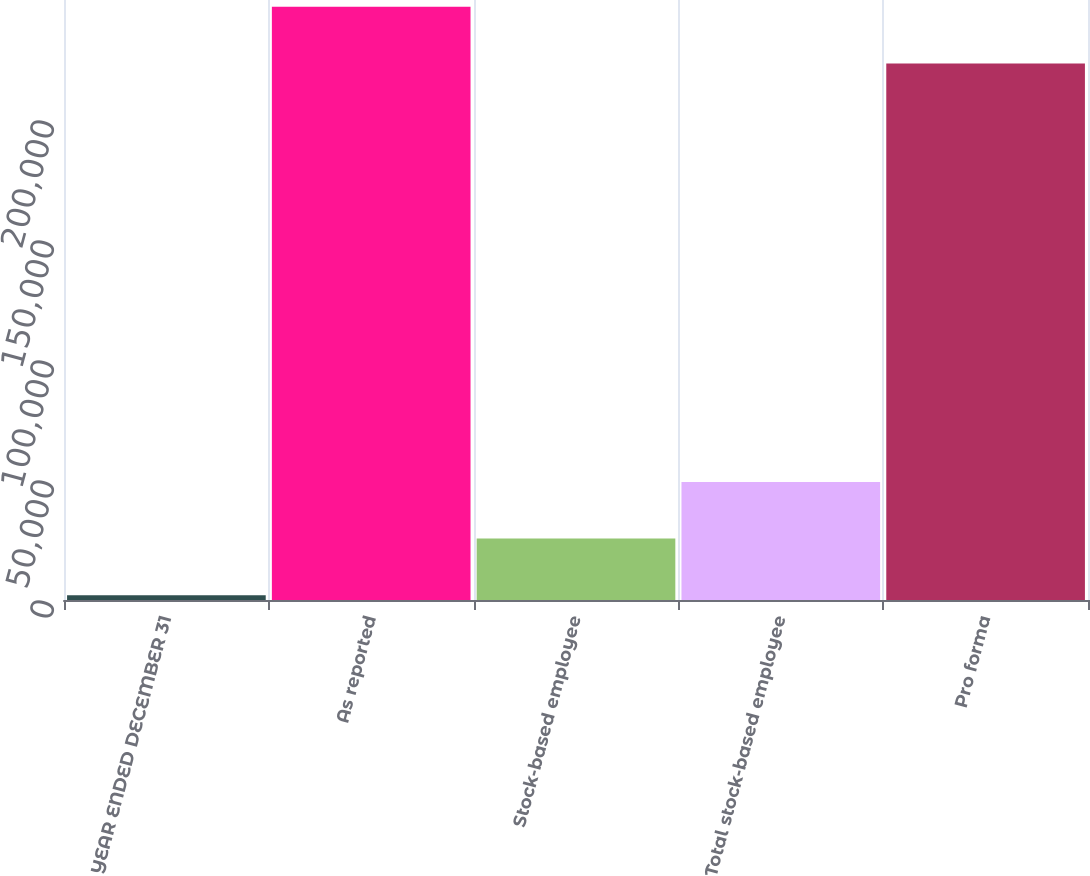<chart> <loc_0><loc_0><loc_500><loc_500><bar_chart><fcel>YEAR ENDED DECEMBER 31<fcel>As reported<fcel>Stock-based employee<fcel>Total stock-based employee<fcel>Pro forma<nl><fcel>2005<fcel>247138<fcel>25591.5<fcel>49178<fcel>223552<nl></chart> 